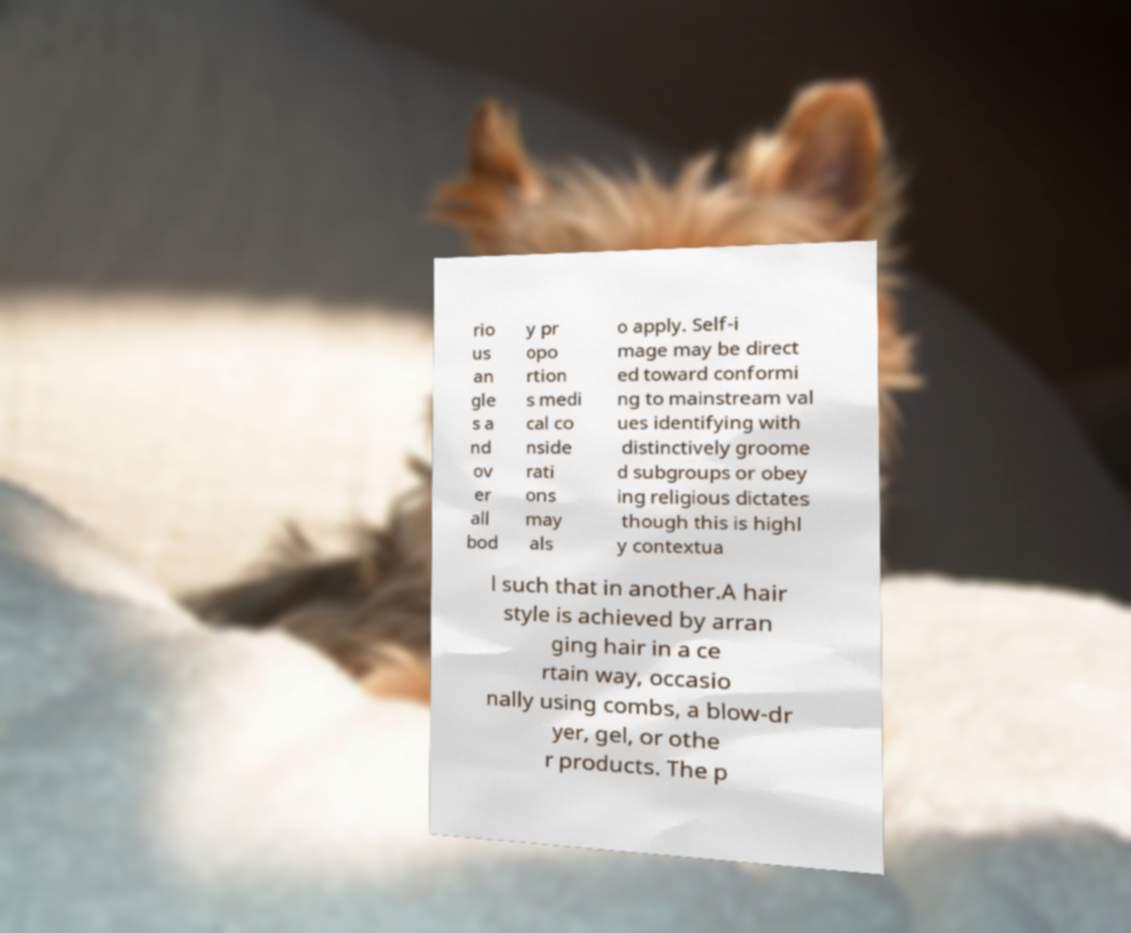There's text embedded in this image that I need extracted. Can you transcribe it verbatim? rio us an gle s a nd ov er all bod y pr opo rtion s medi cal co nside rati ons may als o apply. Self-i mage may be direct ed toward conformi ng to mainstream val ues identifying with distinctively groome d subgroups or obey ing religious dictates though this is highl y contextua l such that in another.A hair style is achieved by arran ging hair in a ce rtain way, occasio nally using combs, a blow-dr yer, gel, or othe r products. The p 